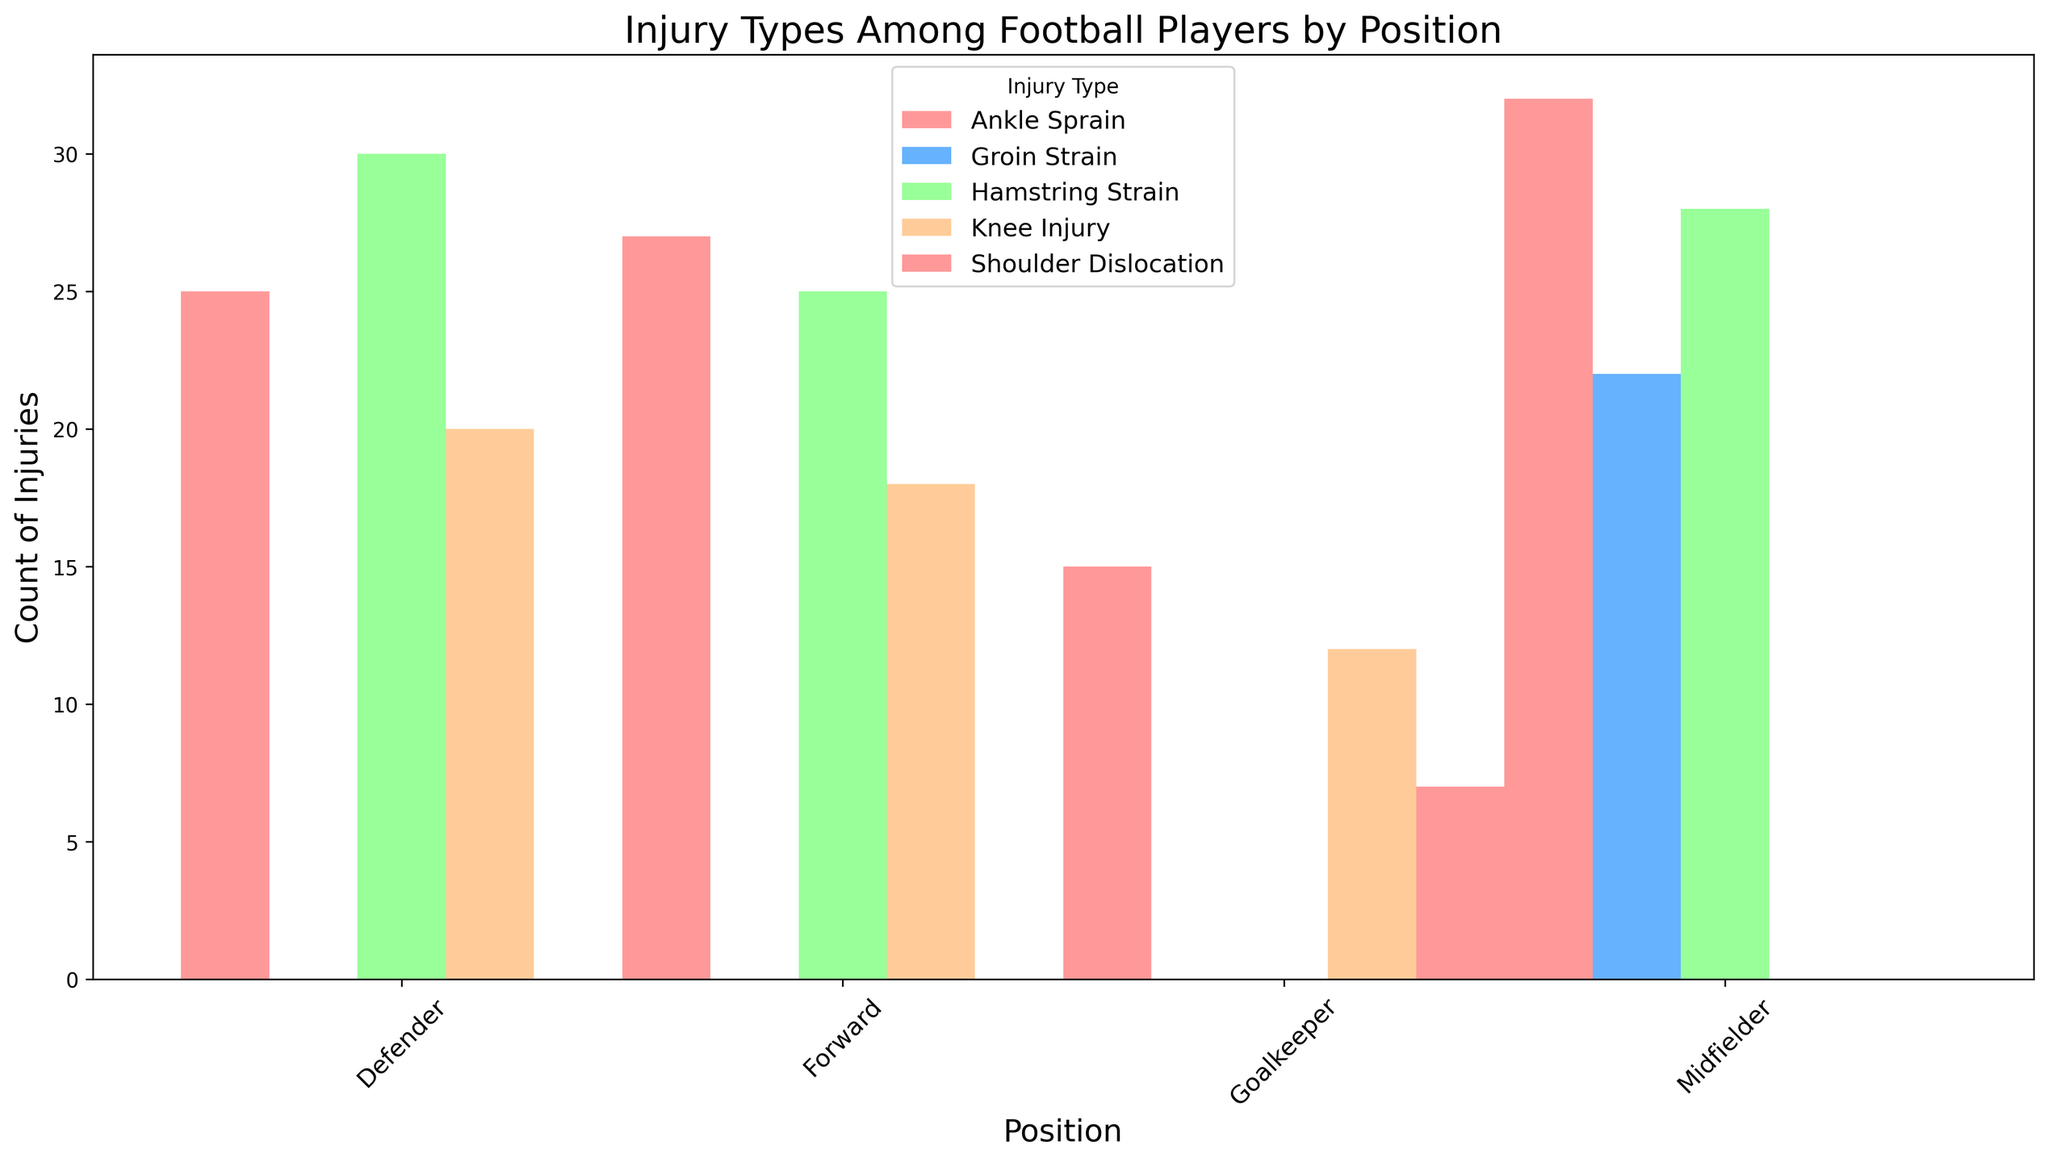Which position has the highest count of Hamstring Strain injuries? Look at the bars representing 'Hamstring Strain' for each position. The tallest bar indicates the highest count. Compare the heights of these bars to determine which is the tallest.
Answer: Defender Which position has the lowest count of Shoulder Dislocation injuries? Observe the bars for 'Shoulder Dislocation' injuries. Identify the position with either no bar or the shortest bar.
Answer: Goalkeeper Which type of injury is most common among Midfielders? Focus on the bars for Midfielders and compare the heights of each injury type. The tallest bar represents the most common injury.
Answer: Ankle Sprain Compare the counts of Knee Injuries between Forwards and Goalkeepers. Which position has more? Compare the heights of the bars representing 'Knee Injury' for Forwards and Goalkeepers. The taller bar indicates the higher count.
Answer: Goalkeeper Summarize the counts of all injuries for Midfielders and compare it to Forwards. Which position has a higher total count? Sum the counts of all injury types for both Midfielders and Forwards. Compare these totals to determine which position is higher. For Midfielders, 28 (Hamstring Strain) + 32 (Ankle Sprain) + 22 (Groin Strain) = 82. For Forwards, 25 (Hamstring Strain) + 18 (Knee Injury) + 27 (Ankle Sprain) = 70.
Answer: Midfielders Which injury type has the highest average count across all positions? Calculate the average count for each injury type by summing their counts across all positions and dividing by the number of positions. Compare these averages to find the highest.
Answer: Ankle Sprain What is the visual difference between the counts of Ankle Sprain and Knee Injury for Defenders? Look at the heights of the bars for 'Ankle Sprain' and 'Knee Injury' for Defenders. Measure the difference in height to determine the visual difference.
Answer: The Ankle Sprain bar is noticeably taller than the Knee Injury bar for Defenders Which position has the highest total count of injuries if we only consider Hamstring Strain and Groin Strain? Sum the counts of 'Hamstring Strain' and 'Groin Strain' for each position. Compare these sums to determine the highest. Defenders: 30 + 0 = 30, Midfielders: 28 + 22 = 50, Forwards: 25 + 0 = 25.
Answer: Midfielders How many more Ankle Sprains do Midfielders have compared to Goalkeepers? Subtract the count of Ankle Sprains for Goalkeepers from that for Midfielders. 32 (Midfielders) - 15 (Goalkeepers) = 17.
Answer: 17 